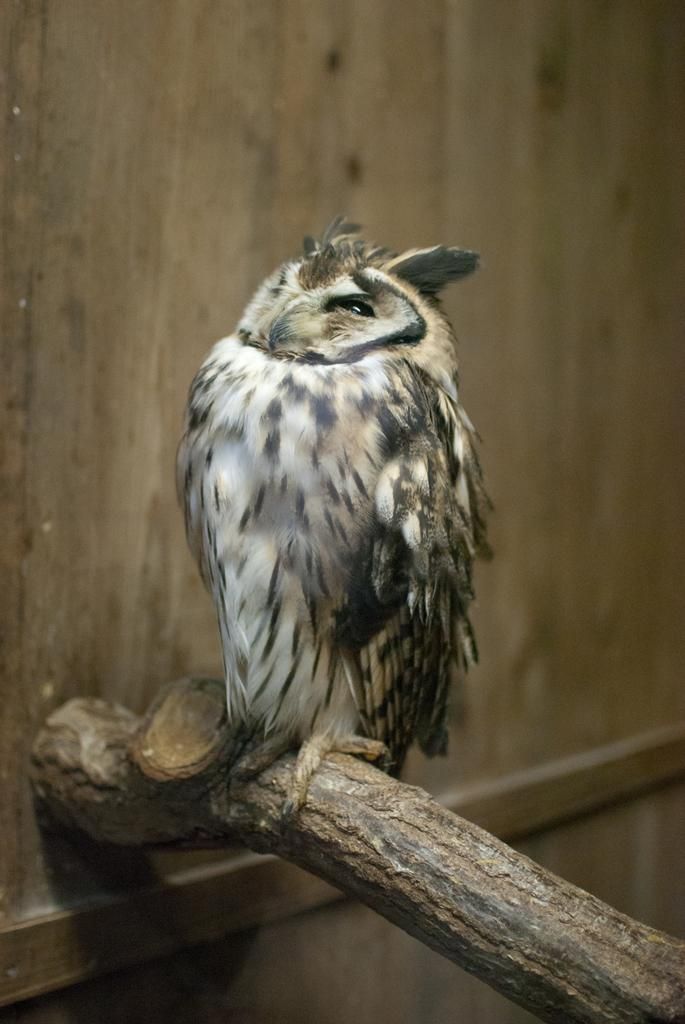What animal is present in the image? There is an owl in the image. Where is the owl located? The owl is on a branch. What is the rate of the passenger train in the image? There is no train or passenger in the image; it features an owl on a branch. 